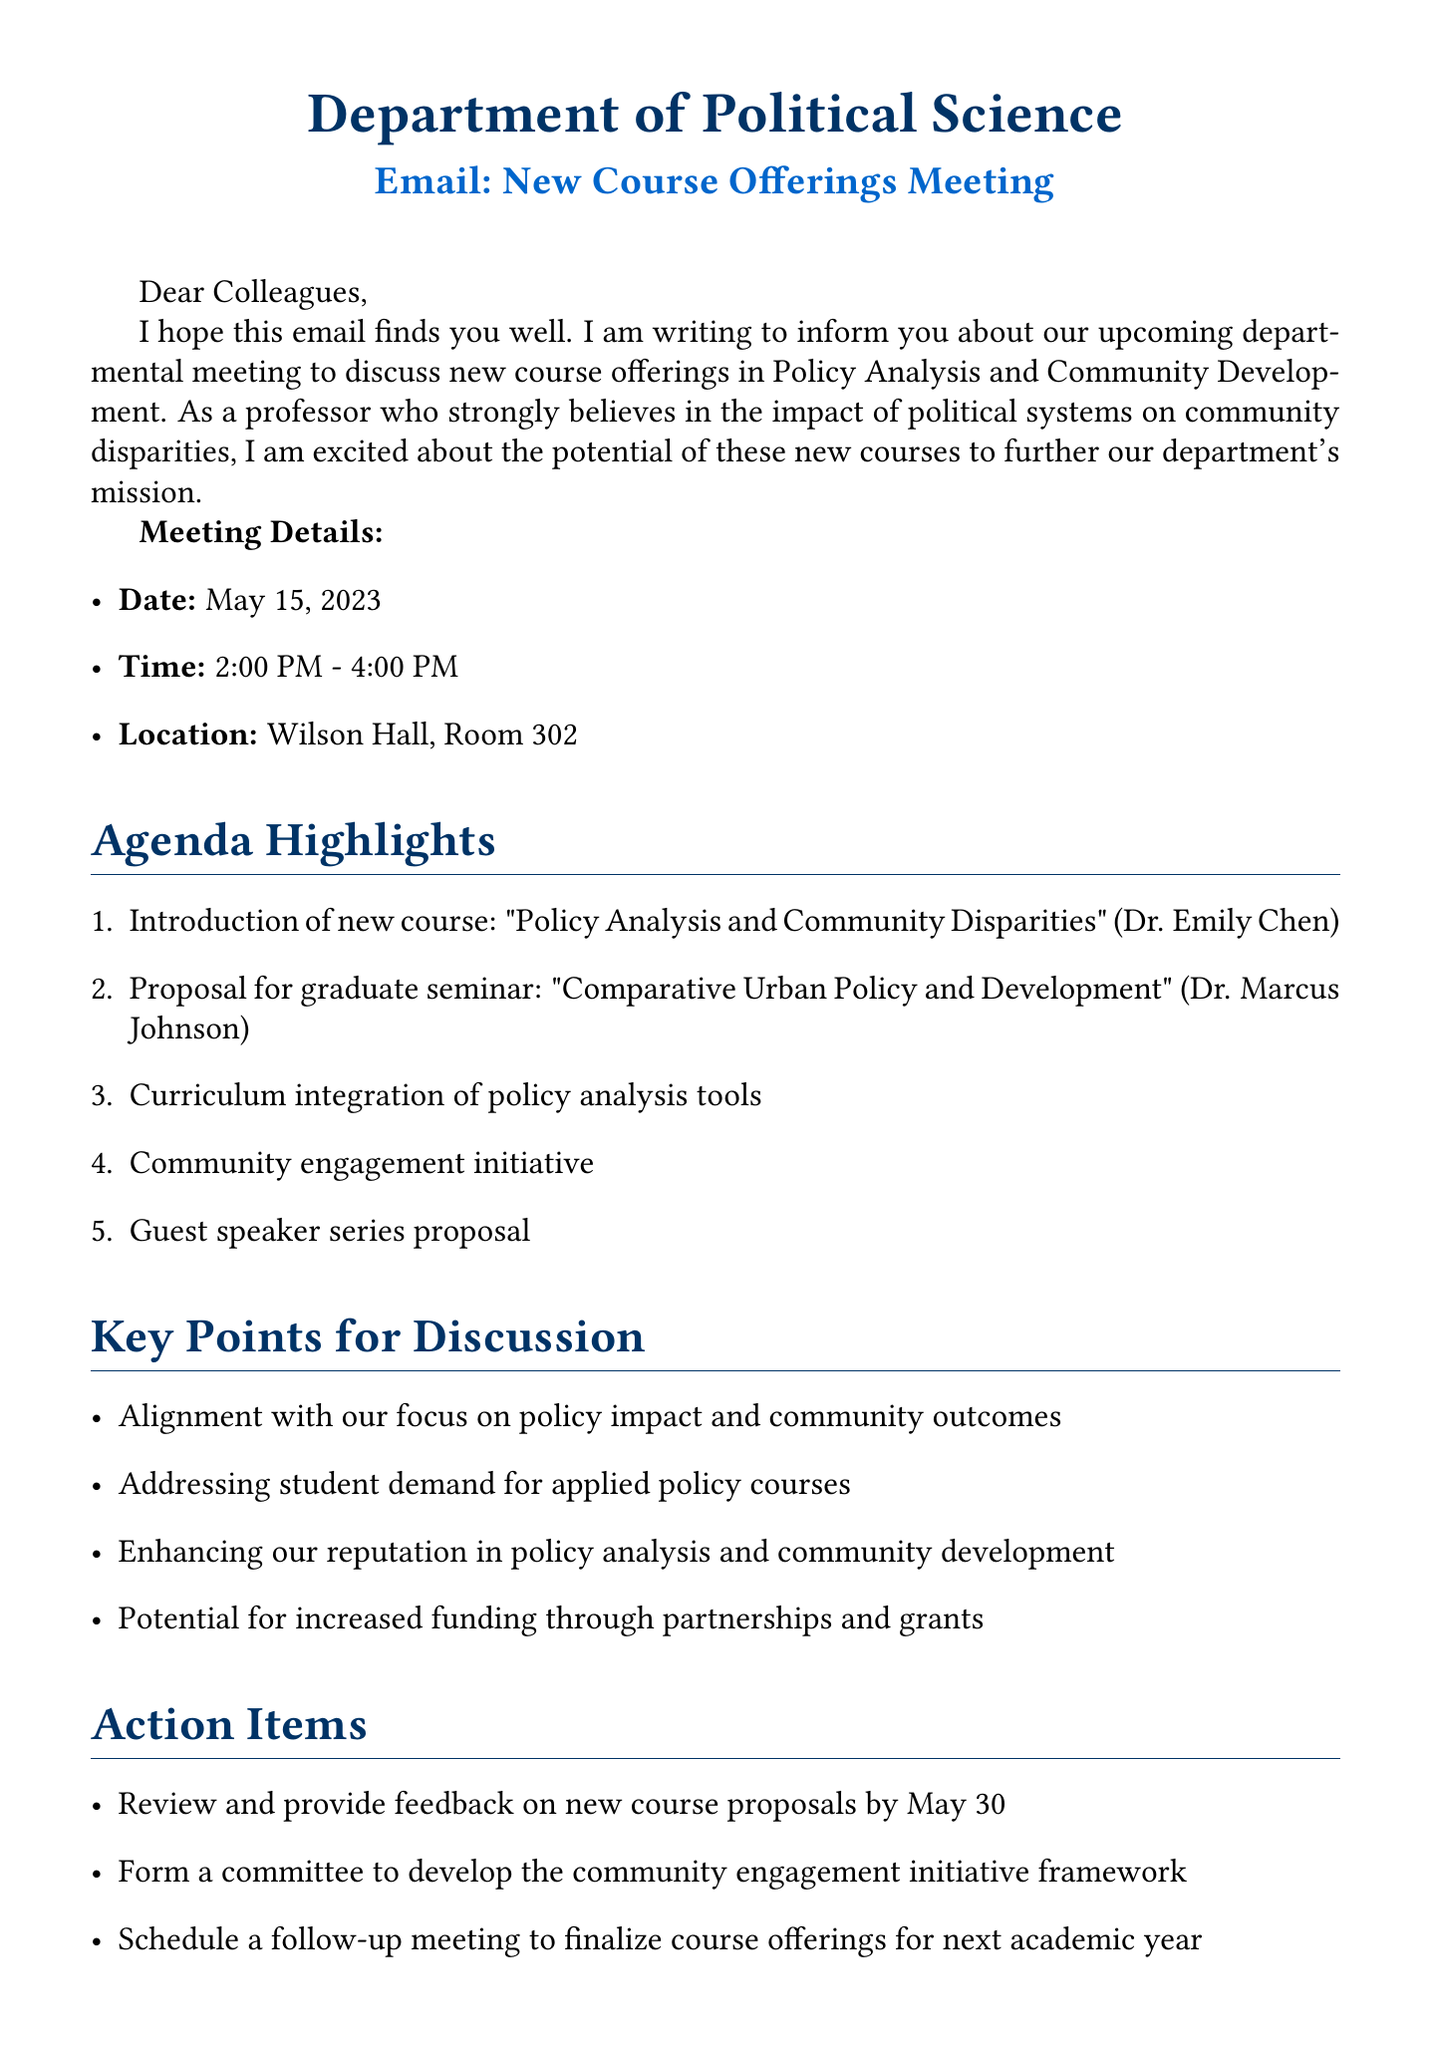What is the date of the departmental meeting? The date of the meeting is stated in the document as May 15, 2023.
Answer: May 15, 2023 Who is the proposed instructor for the course "Policy Analysis and Community Disparities"? The document specifies Dr. Emily Chen as the proposed instructor for this course.
Answer: Dr. Emily Chen What are the hours of the meeting? The meeting time is provided in the document as 2:00 PM - 4:00 PM.
Answer: 2:00 PM - 4:00 PM What is a key point regarding student demand mentioned in the document? The document mentions addressing student demand for more applied policy courses as a key point.
Answer: Applied policy courses What is one of the action items discussed in the meeting? The document lists reviewing and providing feedback on new course proposals by May 30 as one of the action items.
Answer: Review and provide feedback on new course proposals by May 30 What is the location of the meeting? The location of the meeting is given in the document as Wilson Hall, Room 302.
Answer: Wilson Hall, Room 302 What initiative is proposed for community engagement? The document suggests a proposal for a new initiative partnering with local government agencies.
Answer: Partnering with local government agencies What is the title of the proposed graduate seminar? According to the document, the proposed graduate seminar is titled "Comparative Urban Policy and Development."
Answer: Comparative Urban Policy and Development What type of series is proposed to complement the new course offerings? The document proposes a guest speaker series featuring policymakers and community leaders.
Answer: Guest speaker series 